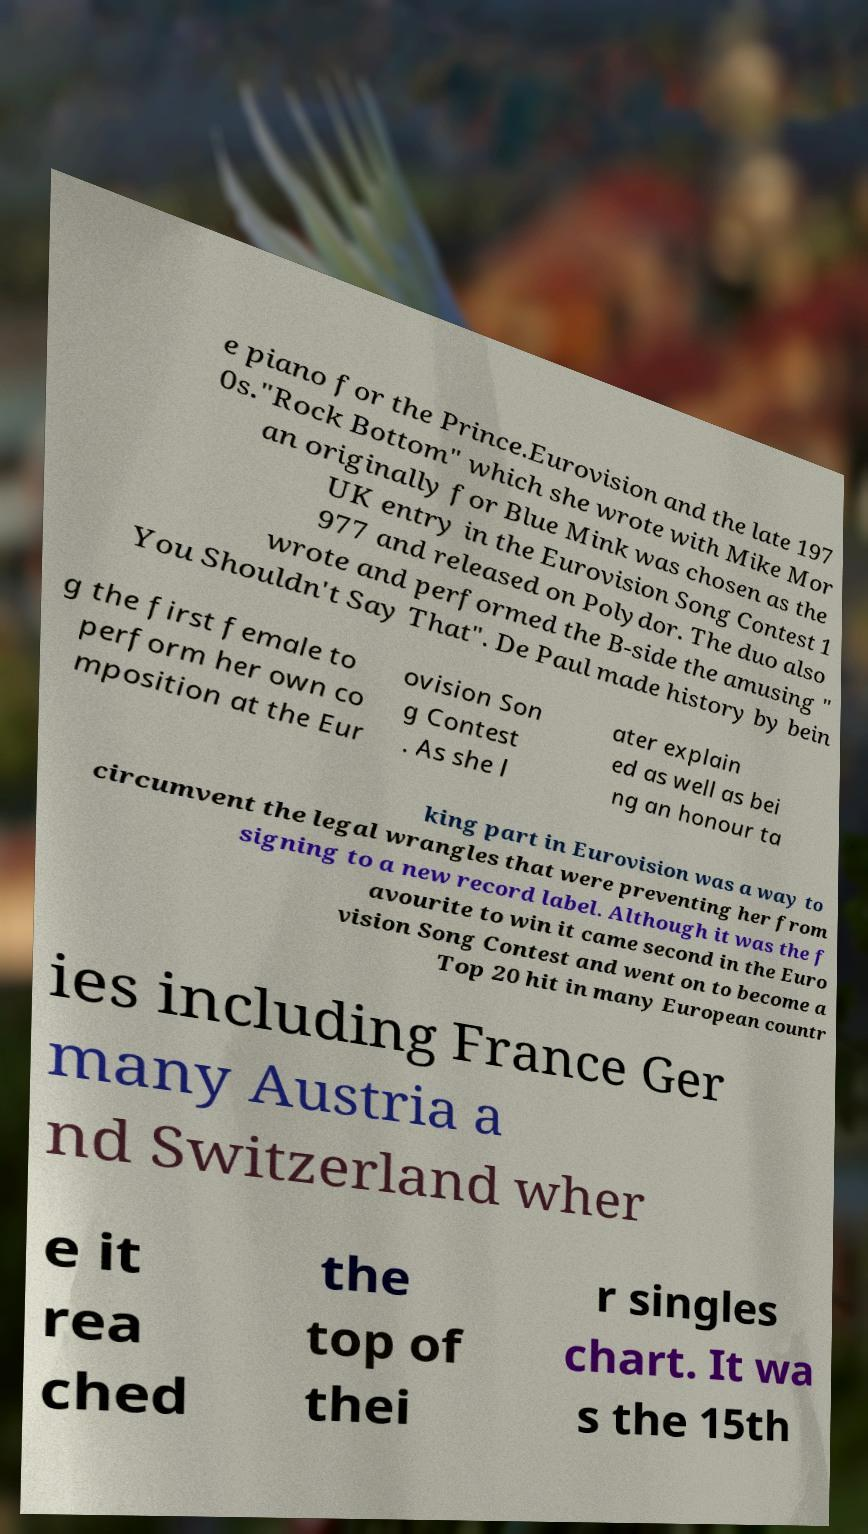Please identify and transcribe the text found in this image. e piano for the Prince.Eurovision and the late 197 0s."Rock Bottom" which she wrote with Mike Mor an originally for Blue Mink was chosen as the UK entry in the Eurovision Song Contest 1 977 and released on Polydor. The duo also wrote and performed the B-side the amusing " You Shouldn't Say That". De Paul made history by bein g the first female to perform her own co mposition at the Eur ovision Son g Contest . As she l ater explain ed as well as bei ng an honour ta king part in Eurovision was a way to circumvent the legal wrangles that were preventing her from signing to a new record label. Although it was the f avourite to win it came second in the Euro vision Song Contest and went on to become a Top 20 hit in many European countr ies including France Ger many Austria a nd Switzerland wher e it rea ched the top of thei r singles chart. It wa s the 15th 